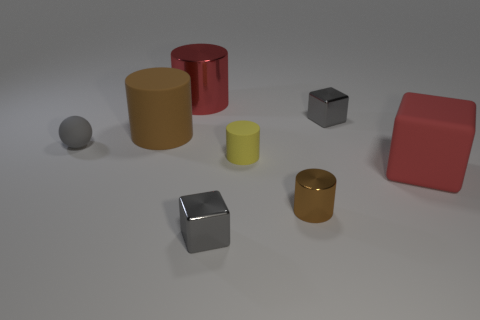Do the rubber block and the metal cylinder that is behind the red rubber block have the same color?
Your response must be concise. Yes. There is a big matte object right of the brown rubber cylinder; is its color the same as the large shiny object?
Offer a very short reply. Yes. Are there any shiny objects that have the same color as the large rubber block?
Provide a succinct answer. Yes. Is the large shiny object the same color as the large block?
Keep it short and to the point. Yes. There is a rubber thing that is the same color as the big metallic cylinder; what is its shape?
Keep it short and to the point. Cube. There is a large red shiny cylinder; are there any brown objects right of it?
Keep it short and to the point. Yes. What color is the cylinder that is the same size as the brown shiny object?
Offer a terse response. Yellow. How many things are either red things left of the rubber block or tiny metal cubes?
Your answer should be compact. 3. What size is the metallic thing that is to the left of the brown metallic object and in front of the sphere?
Your answer should be very brief. Small. What size is the rubber thing that is the same color as the tiny metal cylinder?
Give a very brief answer. Large. 